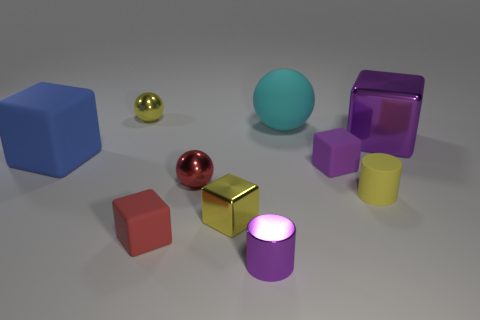What material is the large thing that is the same color as the tiny metal cylinder?
Your response must be concise. Metal. What shape is the yellow metal object right of the small thing that is behind the rubber thing that is to the left of the yellow shiny ball?
Your response must be concise. Cube. Are there fewer small yellow things to the right of the tiny red metallic thing than objects that are behind the big blue matte cube?
Provide a succinct answer. Yes. Are there any tiny things that have the same color as the matte cylinder?
Provide a short and direct response. Yes. Do the yellow block and the yellow object on the right side of the big cyan sphere have the same material?
Give a very brief answer. No. Is there a ball that is to the right of the shiny sphere in front of the large cyan thing?
Give a very brief answer. Yes. There is a small thing that is behind the purple cylinder and in front of the tiny metal cube; what is its color?
Ensure brevity in your answer.  Red. The blue block is what size?
Provide a short and direct response. Large. How many things are the same size as the red sphere?
Your response must be concise. 6. Is the material of the yellow thing in front of the yellow rubber object the same as the tiny sphere in front of the yellow metal sphere?
Give a very brief answer. Yes. 